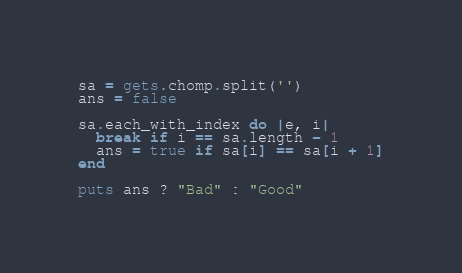Convert code to text. <code><loc_0><loc_0><loc_500><loc_500><_Ruby_>sa = gets.chomp.split('')
ans = false

sa.each_with_index do |e, i|
  break if i == sa.length - 1
  ans = true if sa[i] == sa[i + 1]
end

puts ans ? "Bad" : "Good"
</code> 